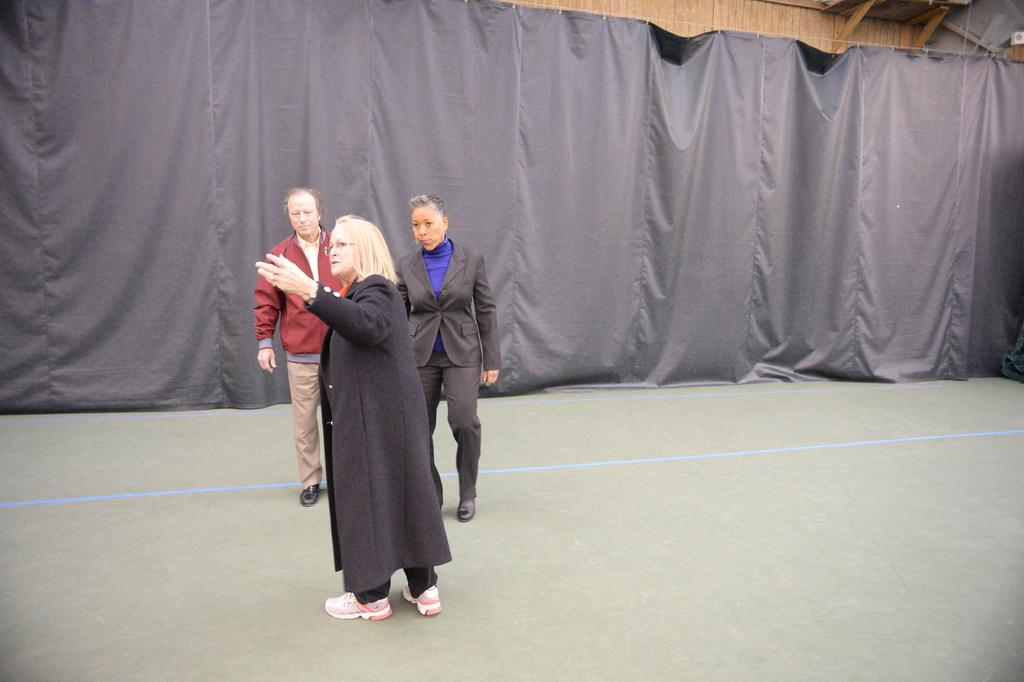What is happening in the image? There are people standing in the image. What can be seen in the background of the image? There is a curtain in the background of the image. What type of coast can be seen in the image? There is no coast visible in the image; it features people standing and a curtain in the background. 